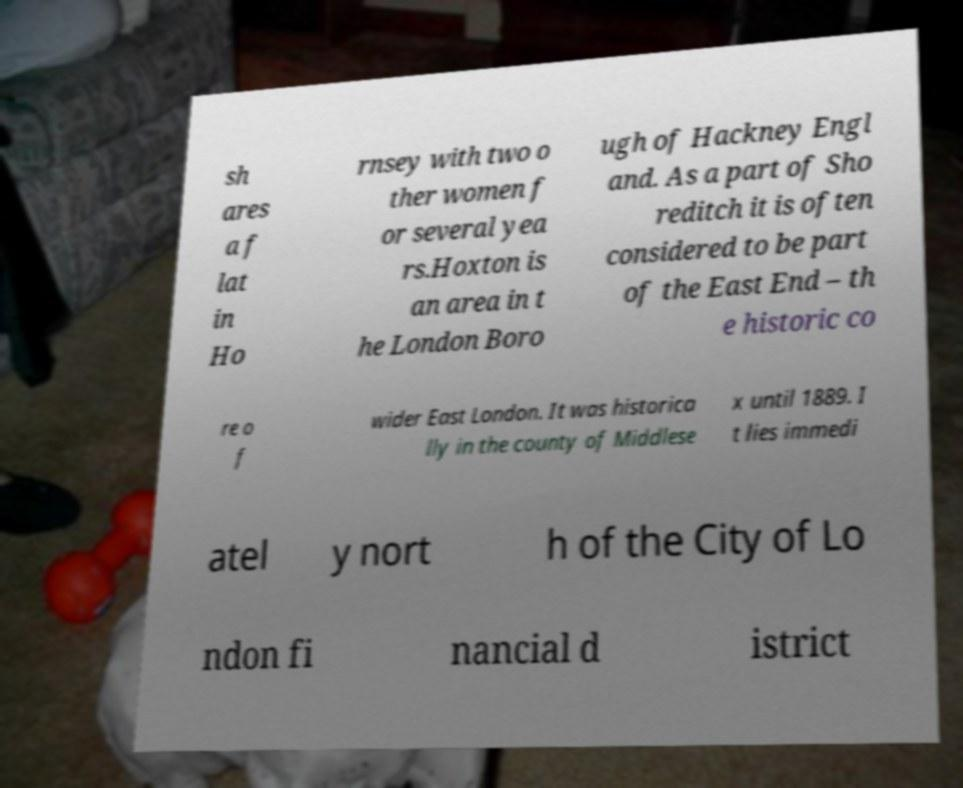Could you extract and type out the text from this image? sh ares a f lat in Ho rnsey with two o ther women f or several yea rs.Hoxton is an area in t he London Boro ugh of Hackney Engl and. As a part of Sho reditch it is often considered to be part of the East End – th e historic co re o f wider East London. It was historica lly in the county of Middlese x until 1889. I t lies immedi atel y nort h of the City of Lo ndon fi nancial d istrict 